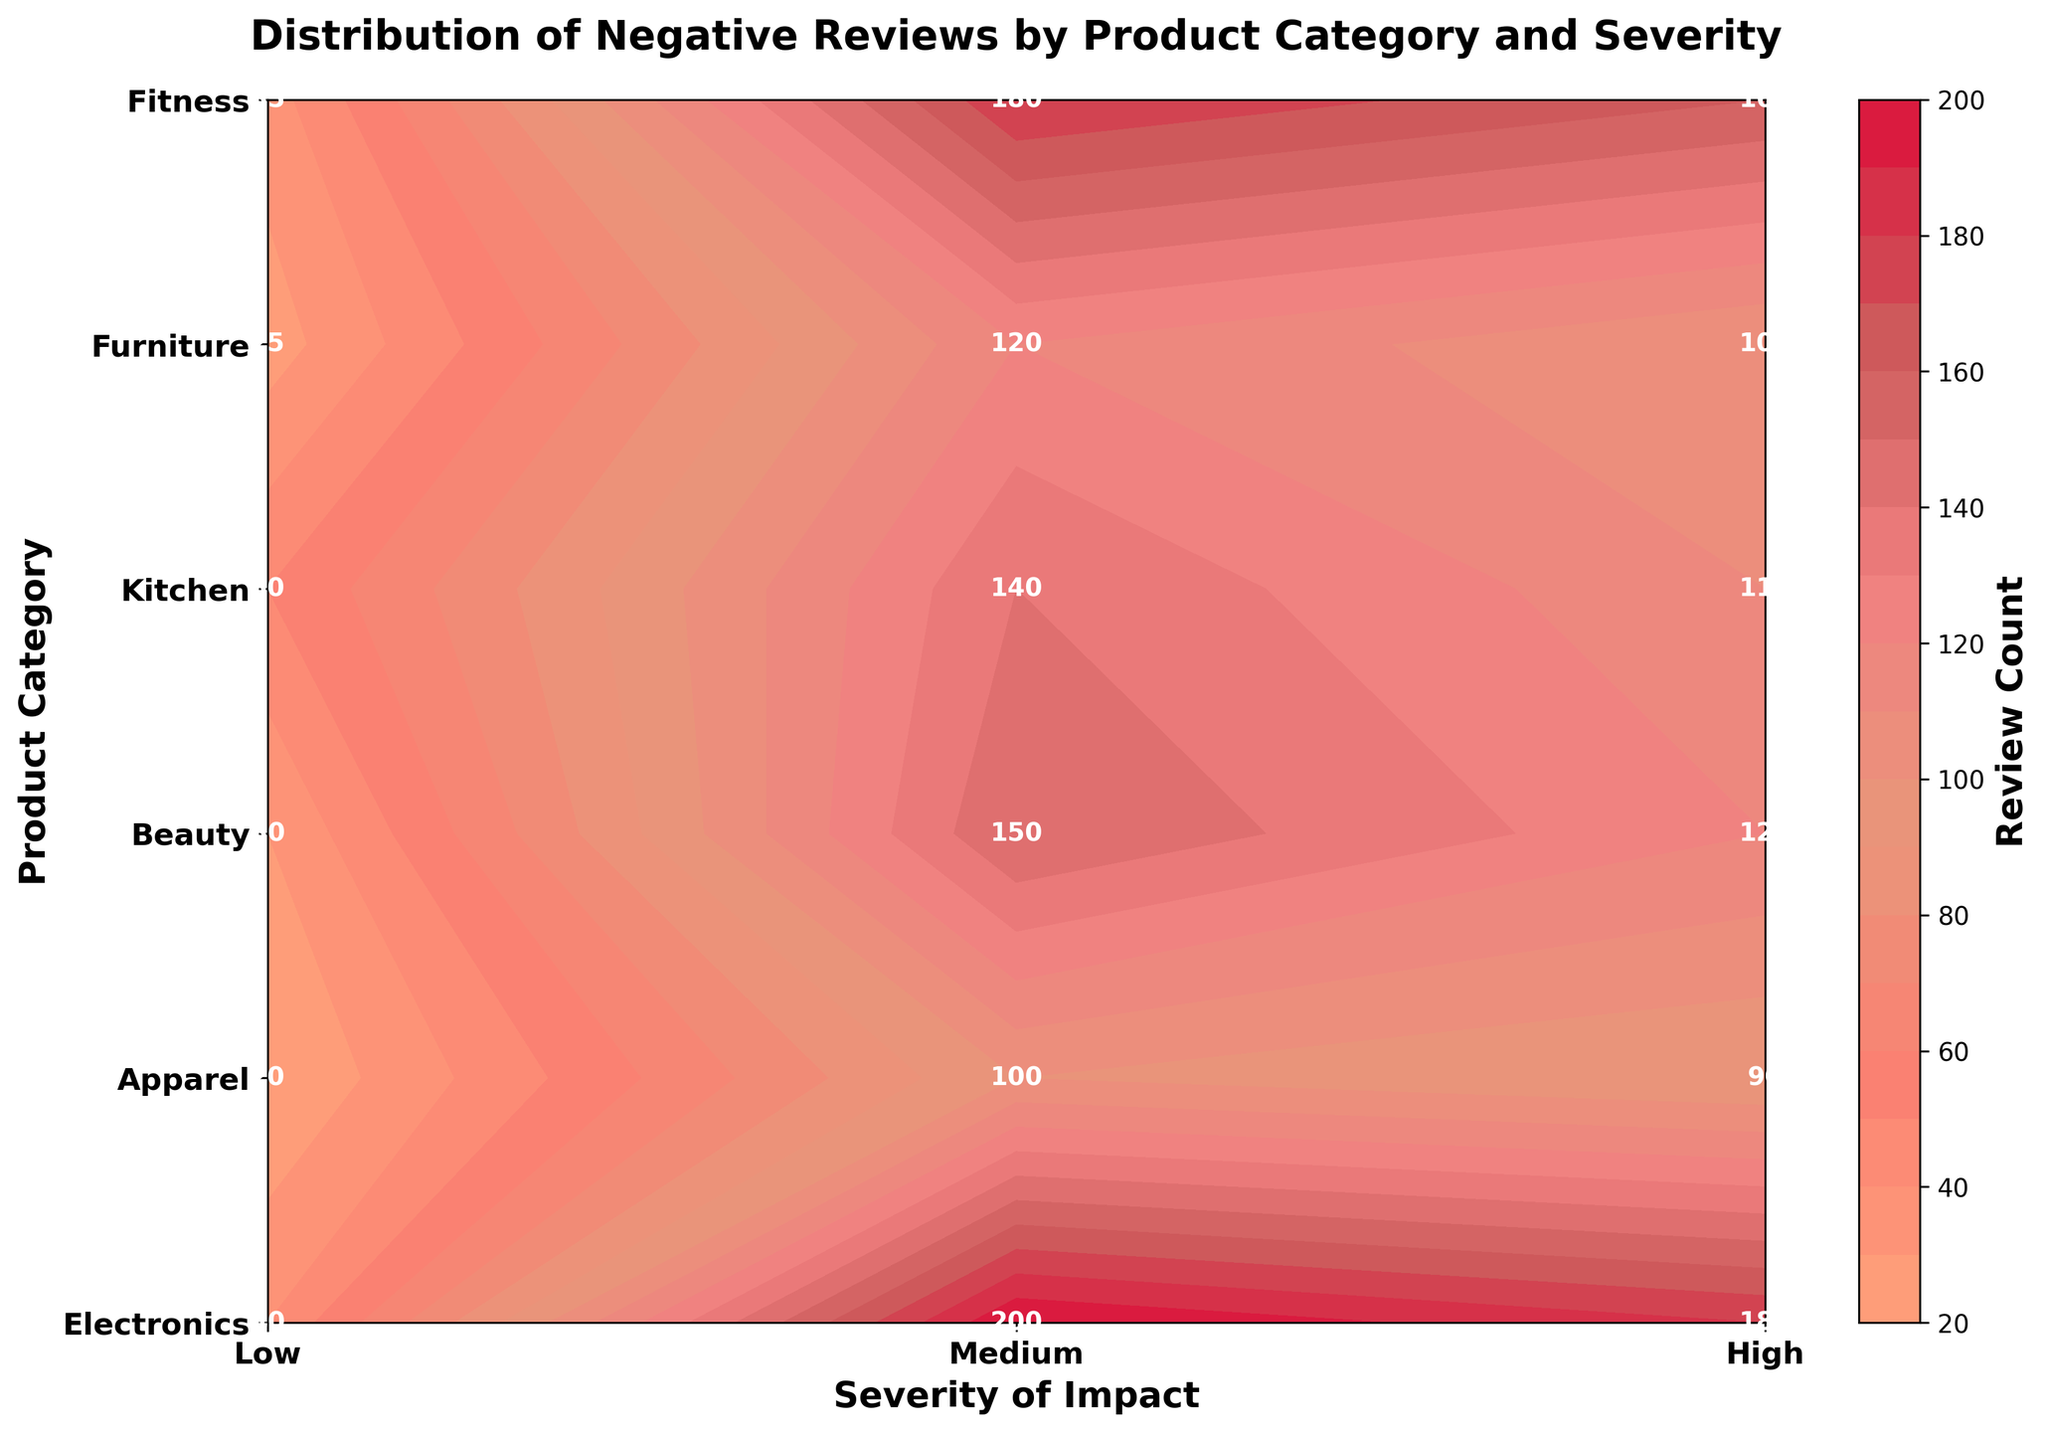What is the title of the figure? The title is displayed at the top of the figure and reads "Distribution of Negative Reviews by Product Category and Severity".
Answer: Distribution of Negative Reviews by Product Category and Severity Which product category has the highest review count for high severity? Look at the 'High' severity column and identify the cell with the highest number. 'Fitness' has the highest value of 50 in this column.
Answer: Fitness Which product category has the lowest review count for medium severity? Look at the 'Medium' severity column and identify the cell with the smallest number. 'Beauty' has the lowest value of 90 in this column.
Answer: Beauty What is the total review count for the 'Electronics' category? Locate the 'Electronics' row and sum the values across all three severity levels: 150 (Low) + 120 (Medium) + 30 (High) = 300.
Answer: 300 What is the average review count for high severity across all product categories? Sum the values in the 'High' severity column and divide by the number of categories. (30 + 40 + 20 + 35 + 25 + 50) / 6 = 200 / 6 ≈ 33.33.
Answer: 33.33 Which category has more reviews for low severity compared to medium severity? Compare the 'Low' and 'Medium' values for each category. 'Apparel', 'Kitchen', and 'Fitness' have 'Low' values greater than 'Medium'.
Answer: Apparel, Kitchen, Fitness Is the review count for 'Furniture' in medium severity greater than in high severity? Compare the values for 'Furniture' in 'Medium' and 'High' columns: 100 (Medium) vs. 25 (High).
Answer: Yes How does the review count for 'Beauty' in medium severity compare to 'Electronics' in medium severity? Compare the values for 'Beauty' and 'Electronics' in 'Medium' column: 90 (Beauty) vs. 120 (Electronics).
Answer: Less What is the range of review counts in the 'Kitchen' category? Identify the minimum and maximum values for the 'Kitchen' category and calculate the difference: 180 (Low) - 35 (High) = 145.
Answer: 145 Which product category has the most even distribution of reviews across all severity levels? Check for the category where the values are closest to each other. 'Fitness' appears to have relatively even values: 140 (Low), 110 (Medium), 50 (High).
Answer: Fitness 